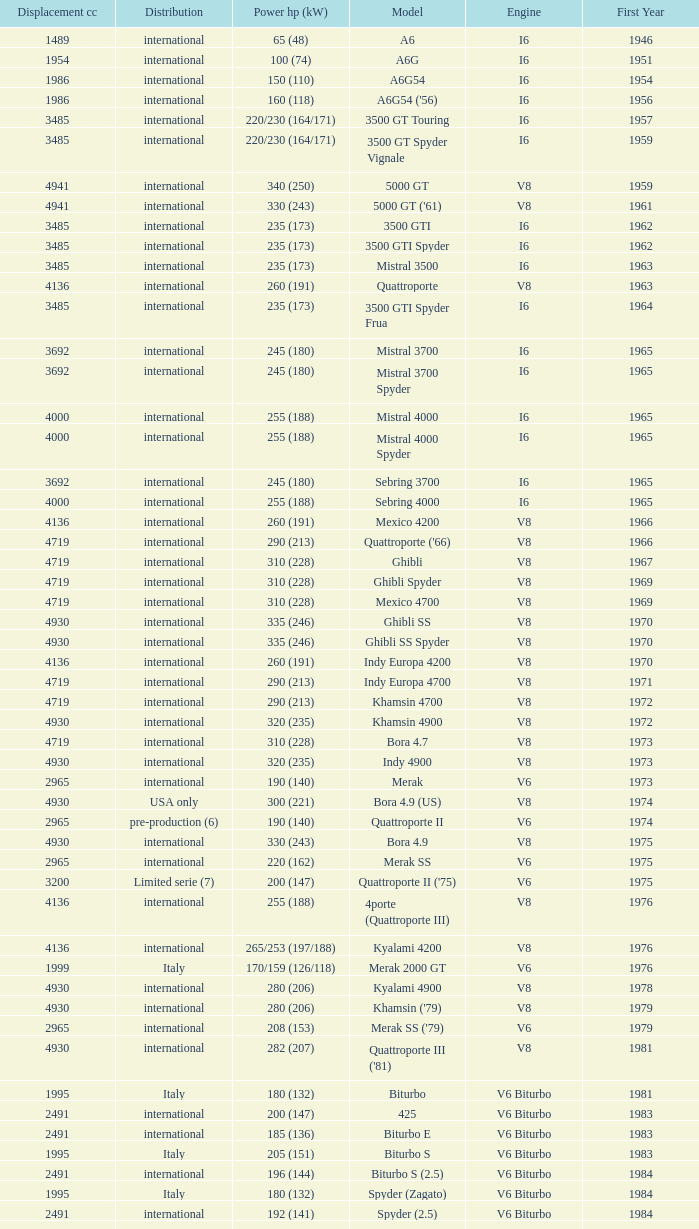What is the lowest First Year, when Model is "Quattroporte (2.8)"? 1994.0. 